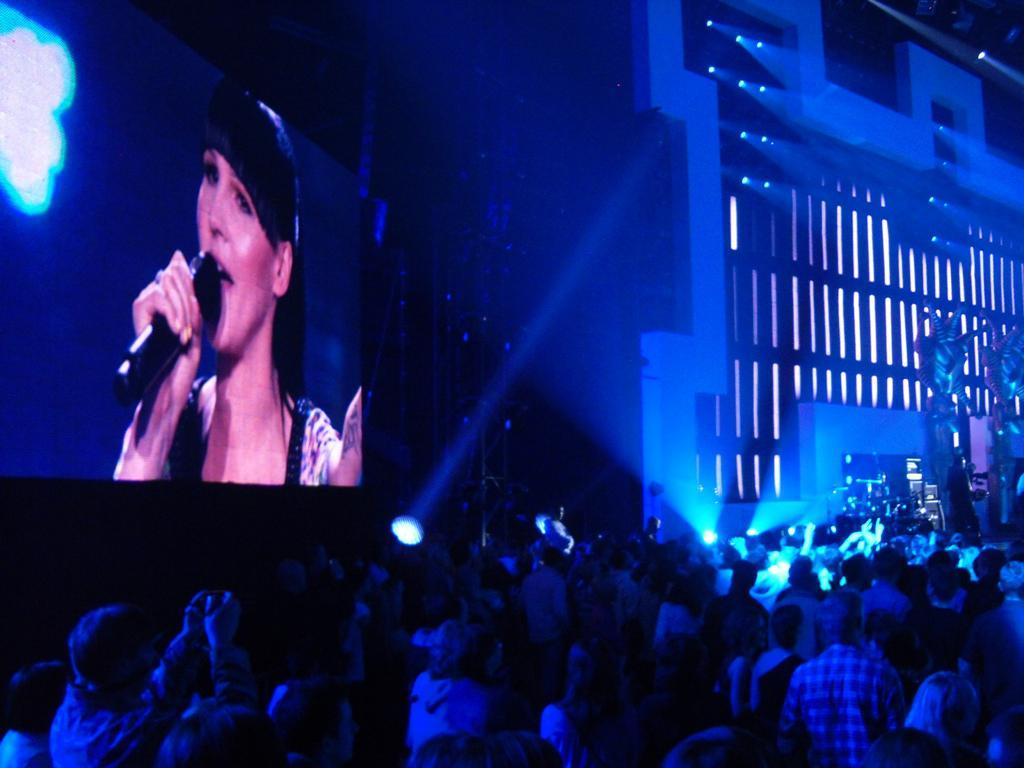How many people are in the image? There is a group of people in the image, but the exact number cannot be determined from the provided facts. What can be seen in the background of the image? There are lights, a screen, and a building in the background of the image. What type of wool is being used to attack the building in the image? There is no wool or attack present in the image; it features a group of people and a background with lights, a screen, and a building. 